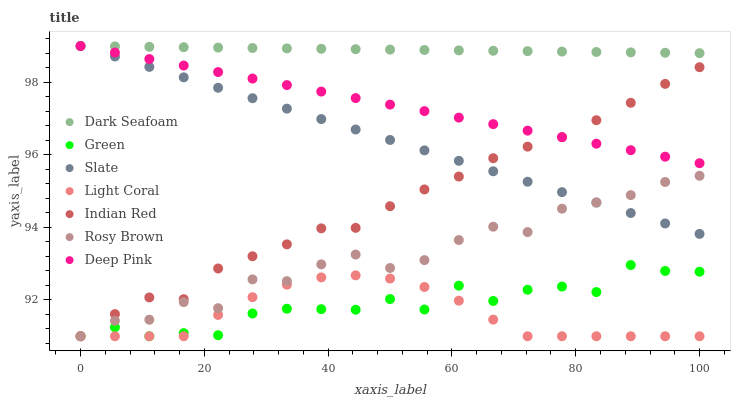Does Light Coral have the minimum area under the curve?
Answer yes or no. Yes. Does Dark Seafoam have the maximum area under the curve?
Answer yes or no. Yes. Does Slate have the minimum area under the curve?
Answer yes or no. No. Does Slate have the maximum area under the curve?
Answer yes or no. No. Is Deep Pink the smoothest?
Answer yes or no. Yes. Is Green the roughest?
Answer yes or no. Yes. Is Slate the smoothest?
Answer yes or no. No. Is Slate the roughest?
Answer yes or no. No. Does Rosy Brown have the lowest value?
Answer yes or no. Yes. Does Slate have the lowest value?
Answer yes or no. No. Does Dark Seafoam have the highest value?
Answer yes or no. Yes. Does Rosy Brown have the highest value?
Answer yes or no. No. Is Rosy Brown less than Deep Pink?
Answer yes or no. Yes. Is Dark Seafoam greater than Indian Red?
Answer yes or no. Yes. Does Rosy Brown intersect Slate?
Answer yes or no. Yes. Is Rosy Brown less than Slate?
Answer yes or no. No. Is Rosy Brown greater than Slate?
Answer yes or no. No. Does Rosy Brown intersect Deep Pink?
Answer yes or no. No. 